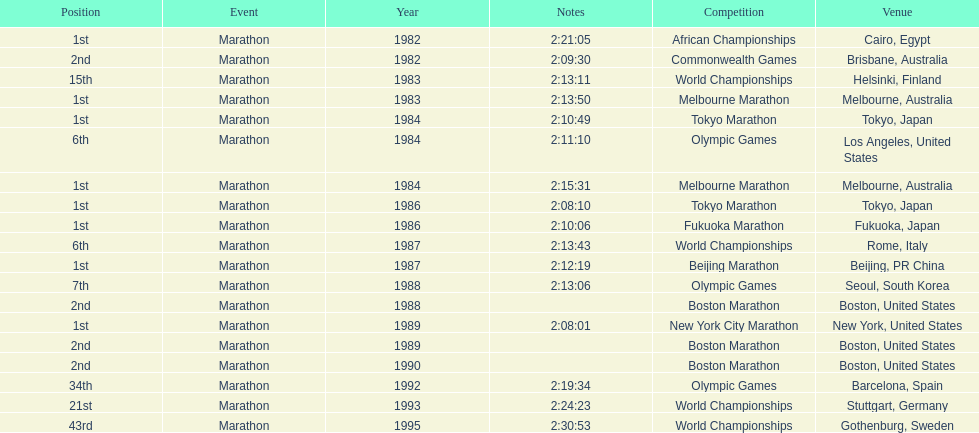Which competition is listed the most in this chart? World Championships. Parse the table in full. {'header': ['Position', 'Event', 'Year', 'Notes', 'Competition', 'Venue'], 'rows': [['1st', 'Marathon', '1982', '2:21:05', 'African Championships', 'Cairo, Egypt'], ['2nd', 'Marathon', '1982', '2:09:30', 'Commonwealth Games', 'Brisbane, Australia'], ['15th', 'Marathon', '1983', '2:13:11', 'World Championships', 'Helsinki, Finland'], ['1st', 'Marathon', '1983', '2:13:50', 'Melbourne Marathon', 'Melbourne, Australia'], ['1st', 'Marathon', '1984', '2:10:49', 'Tokyo Marathon', 'Tokyo, Japan'], ['6th', 'Marathon', '1984', '2:11:10', 'Olympic Games', 'Los Angeles, United States'], ['1st', 'Marathon', '1984', '2:15:31', 'Melbourne Marathon', 'Melbourne, Australia'], ['1st', 'Marathon', '1986', '2:08:10', 'Tokyo Marathon', 'Tokyo, Japan'], ['1st', 'Marathon', '1986', '2:10:06', 'Fukuoka Marathon', 'Fukuoka, Japan'], ['6th', 'Marathon', '1987', '2:13:43', 'World Championships', 'Rome, Italy'], ['1st', 'Marathon', '1987', '2:12:19', 'Beijing Marathon', 'Beijing, PR China'], ['7th', 'Marathon', '1988', '2:13:06', 'Olympic Games', 'Seoul, South Korea'], ['2nd', 'Marathon', '1988', '', 'Boston Marathon', 'Boston, United States'], ['1st', 'Marathon', '1989', '2:08:01', 'New York City Marathon', 'New York, United States'], ['2nd', 'Marathon', '1989', '', 'Boston Marathon', 'Boston, United States'], ['2nd', 'Marathon', '1990', '', 'Boston Marathon', 'Boston, United States'], ['34th', 'Marathon', '1992', '2:19:34', 'Olympic Games', 'Barcelona, Spain'], ['21st', 'Marathon', '1993', '2:24:23', 'World Championships', 'Stuttgart, Germany'], ['43rd', 'Marathon', '1995', '2:30:53', 'World Championships', 'Gothenburg, Sweden']]} 